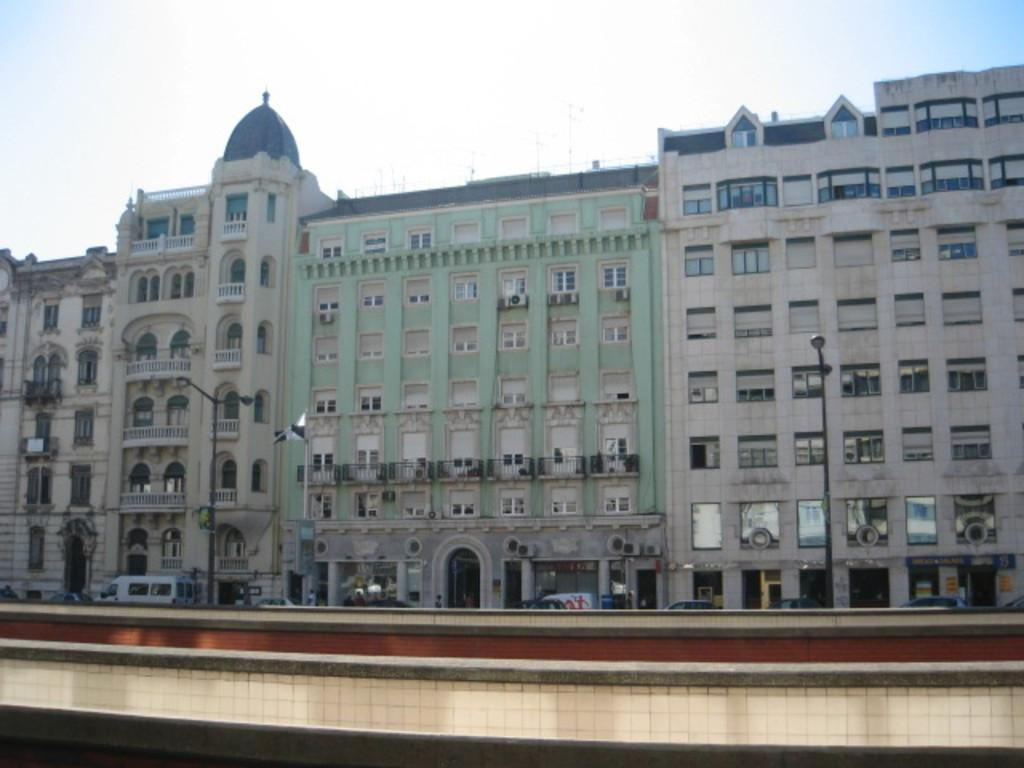What type of structures can be seen in the image? There are buildings in the image. What type of lighting is present in the image? There are pole lights in the image. What type of transportation is visible in the image? There are vehicles in the image. How would you describe the sky in the image? The sky is blue and cloudy in the image. What type of drink is being served in the image? There is no drink present in the image. Can you tell me who is having an argument in the image? There is no argument present in the image. Where is the loaf of bread located in the image? There is no loaf of bread present in the image. 